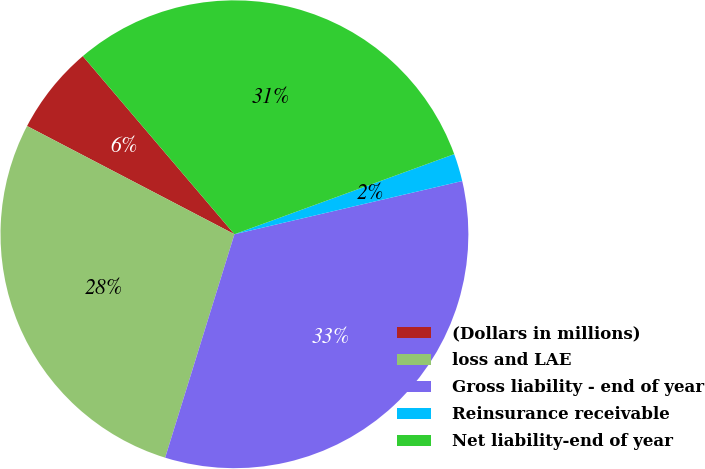<chart> <loc_0><loc_0><loc_500><loc_500><pie_chart><fcel>(Dollars in millions)<fcel>loss and LAE<fcel>Gross liability - end of year<fcel>Reinsurance receivable<fcel>Net liability-end of year<nl><fcel>6.12%<fcel>27.87%<fcel>33.44%<fcel>1.91%<fcel>30.66%<nl></chart> 